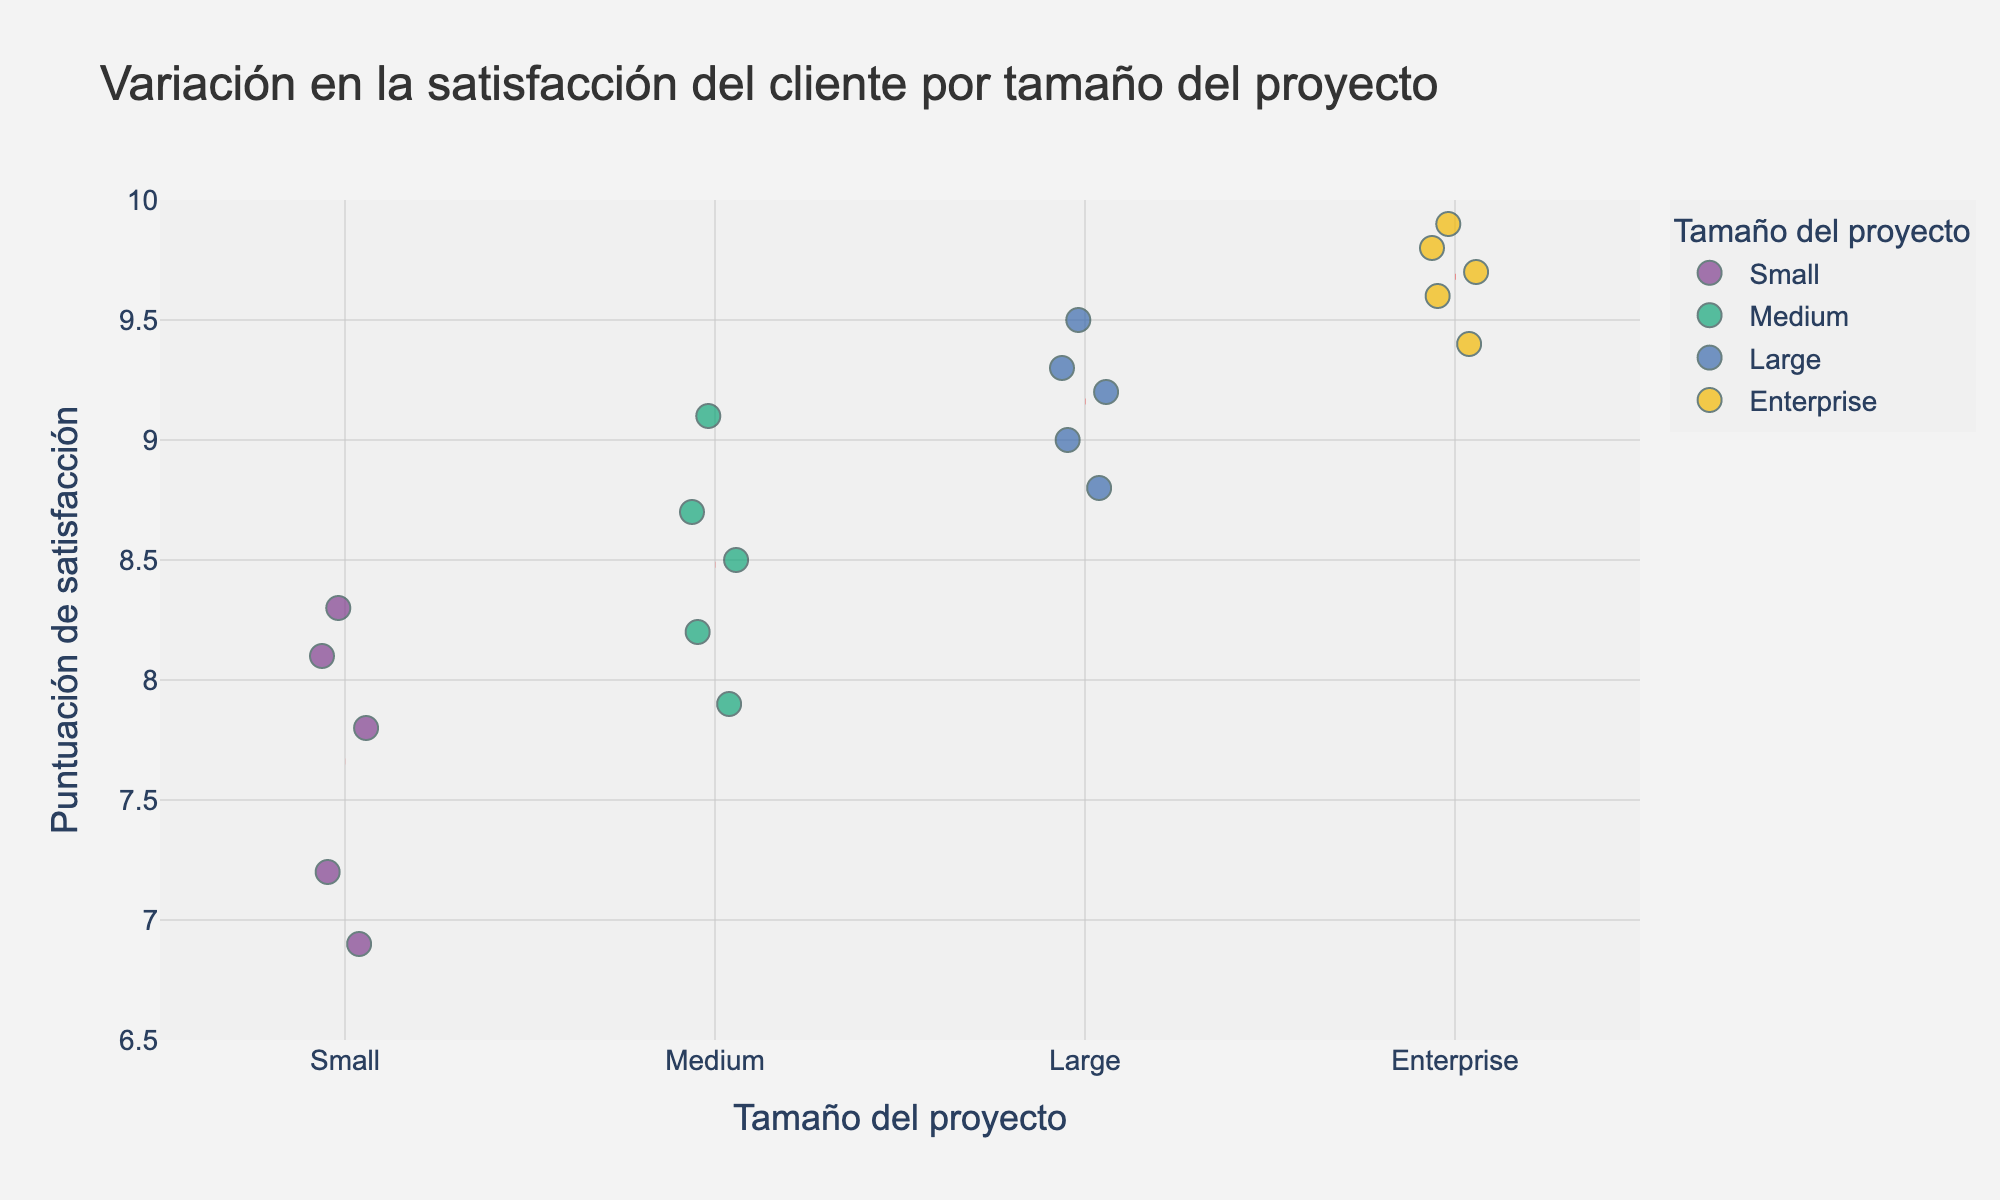What is the title of the plot? The title is typically shown at the top of the plot. It provides a summary of the visual information presented. The title of the plot is "Variación en la satisfacción del cliente por tamaño del proyecto."
Answer: "Variación en la satisfacción del cliente por tamaño del proyecto" How are the project sizes differentiated in the plot? The project sizes are differentiated by the color of the markers. Each project size (Small, Medium, Large, Enterprise) has a distinct color, which is consistent throughout the plot. This helps to visually separate and identify different project sizes.
Answer: By color What is the range of client satisfaction scores for Medium-sized projects? By observing the y-axis values for Medium-sized project markers, we see that these values range from the lowest to the highest point. The client satisfaction scores for Medium-sized projects range from 7.9 to 9.1.
Answer: From 7.9 to 9.1 Which project size has the highest mean client satisfaction score? The mean lines across the project sizes help identify this. The red dashed lines indicate the mean scores, with the Enterprise-size projects having the highest mean score because its line is placed highest on the y-axis.
Answer: Enterprise What is the difference between the highest and lowest client satisfaction scores for Small projects? The data points for Small-sized projects range from 6.9 to 8.3 on the y-axis. To find the difference, subtract the lowest score from the highest score: 8.3 - 6.9 = 1.4.
Answer: 1.4 Which project size shows the greatest variation in client satisfaction scores? Variation can be interpreted by observing the spread of the data points for each project size. Small-sized projects have the widest spread from 6.9 to 8.3, indicating the greatest variation.
Answer: Small How many data points are presented for each project size? By counting the markers (or data points) for each project size along the x-axis: Small (5 data points), Medium (5 data points), Large (5 data points), Enterprise (5 data points).
Answer: 5 for each What can you infer about client satisfaction as project size increases? By observing the trend of client satisfaction scores, we see that as the project size increases, the general trend of client satisfaction scores also increases. The highest scores are observed in Enterprise-size projects, while the lowest are in Small-sized projects. This implies better client satisfaction with larger project sizes.
Answer: Client satisfaction generally increases with project size Which project size has the most consistent client satisfaction scores? Consistency in client satisfaction scores implies a small range or deviation. Enterprise projects show the least variation (smallest range from 9.4 to 9.9), indicating the most consistent satisfaction scores.
Answer: Enterprise 